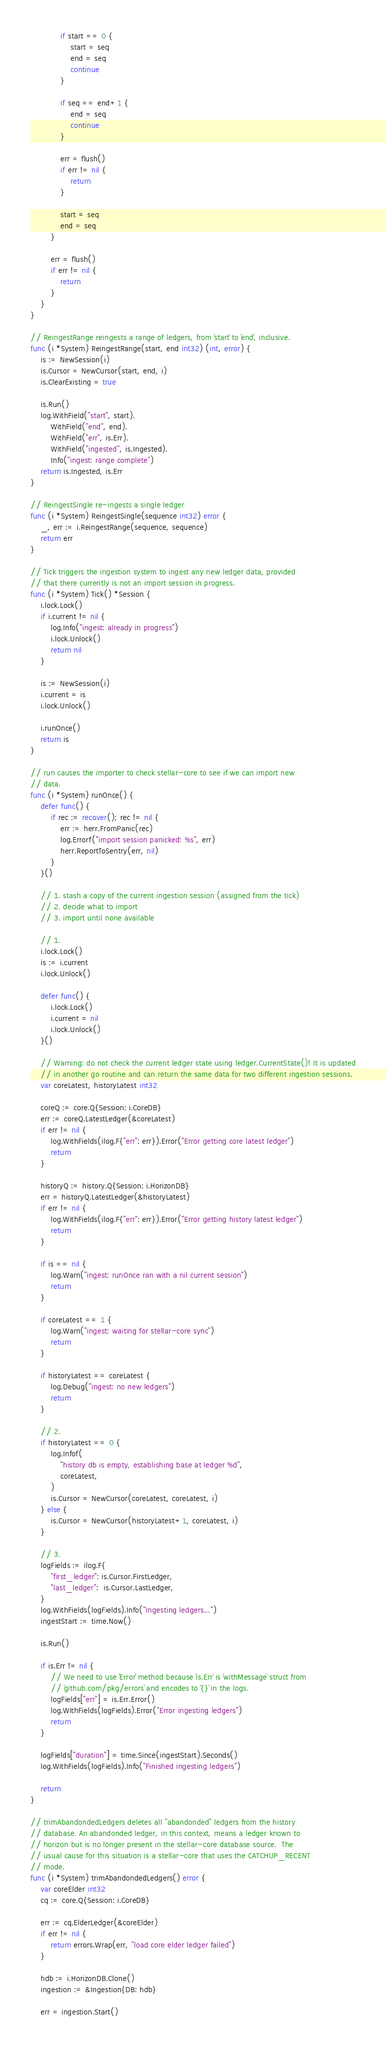Convert code to text. <code><loc_0><loc_0><loc_500><loc_500><_Go_>
			if start == 0 {
				start = seq
				end = seq
				continue
			}

			if seq == end+1 {
				end = seq
				continue
			}

			err = flush()
			if err != nil {
				return
			}

			start = seq
			end = seq
		}

		err = flush()
		if err != nil {
			return
		}
	}
}

// ReingestRange reingests a range of ledgers, from `start` to `end`, inclusive.
func (i *System) ReingestRange(start, end int32) (int, error) {
	is := NewSession(i)
	is.Cursor = NewCursor(start, end, i)
	is.ClearExisting = true

	is.Run()
	log.WithField("start", start).
		WithField("end", end).
		WithField("err", is.Err).
		WithField("ingested", is.Ingested).
		Info("ingest: range complete")
	return is.Ingested, is.Err
}

// ReingestSingle re-ingests a single ledger
func (i *System) ReingestSingle(sequence int32) error {
	_, err := i.ReingestRange(sequence, sequence)
	return err
}

// Tick triggers the ingestion system to ingest any new ledger data, provided
// that there currently is not an import session in progress.
func (i *System) Tick() *Session {
	i.lock.Lock()
	if i.current != nil {
		log.Info("ingest: already in progress")
		i.lock.Unlock()
		return nil
	}

	is := NewSession(i)
	i.current = is
	i.lock.Unlock()

	i.runOnce()
	return is
}

// run causes the importer to check stellar-core to see if we can import new
// data.
func (i *System) runOnce() {
	defer func() {
		if rec := recover(); rec != nil {
			err := herr.FromPanic(rec)
			log.Errorf("import session panicked: %s", err)
			herr.ReportToSentry(err, nil)
		}
	}()

	// 1. stash a copy of the current ingestion session (assigned from the tick)
	// 2. decide what to import
	// 3. import until none available

	// 1.
	i.lock.Lock()
	is := i.current
	i.lock.Unlock()

	defer func() {
		i.lock.Lock()
		i.current = nil
		i.lock.Unlock()
	}()

	// Warning: do not check the current ledger state using ledger.CurrentState()! It is updated
	// in another go routine and can return the same data for two different ingestion sessions.
	var coreLatest, historyLatest int32

	coreQ := core.Q{Session: i.CoreDB}
	err := coreQ.LatestLedger(&coreLatest)
	if err != nil {
		log.WithFields(ilog.F{"err": err}).Error("Error getting core latest ledger")
		return
	}

	historyQ := history.Q{Session: i.HorizonDB}
	err = historyQ.LatestLedger(&historyLatest)
	if err != nil {
		log.WithFields(ilog.F{"err": err}).Error("Error getting history latest ledger")
		return
	}

	if is == nil {
		log.Warn("ingest: runOnce ran with a nil current session")
		return
	}

	if coreLatest == 1 {
		log.Warn("ingest: waiting for stellar-core sync")
		return
	}

	if historyLatest == coreLatest {
		log.Debug("ingest: no new ledgers")
		return
	}

	// 2.
	if historyLatest == 0 {
		log.Infof(
			"history db is empty, establishing base at ledger %d",
			coreLatest,
		)
		is.Cursor = NewCursor(coreLatest, coreLatest, i)
	} else {
		is.Cursor = NewCursor(historyLatest+1, coreLatest, i)
	}

	// 3.
	logFields := ilog.F{
		"first_ledger": is.Cursor.FirstLedger,
		"last_ledger":  is.Cursor.LastLedger,
	}
	log.WithFields(logFields).Info("Ingesting ledgers...")
	ingestStart := time.Now()

	is.Run()

	if is.Err != nil {
		// We need to use `Error` method because `is.Err` is `withMessage` struct from
		// `github.com/pkg/errors` and encodes to `{}` in the logs.
		logFields["err"] = is.Err.Error()
		log.WithFields(logFields).Error("Error ingesting ledgers")
		return
	}

	logFields["duration"] = time.Since(ingestStart).Seconds()
	log.WithFields(logFields).Info("Finished ingesting ledgers")

	return
}

// trimAbandondedLedgers deletes all "abandonded" ledgers from the history
// database. An abandonded ledger, in this context, means a ledger known to
// horizon but is no longer present in the stellar-core database source.  The
// usual cause for this situation is a stellar-core that uses the CATCHUP_RECENT
// mode.
func (i *System) trimAbandondedLedgers() error {
	var coreElder int32
	cq := core.Q{Session: i.CoreDB}

	err := cq.ElderLedger(&coreElder)
	if err != nil {
		return errors.Wrap(err, "load core elder ledger failed")
	}

	hdb := i.HorizonDB.Clone()
	ingestion := &Ingestion{DB: hdb}

	err = ingestion.Start()</code> 